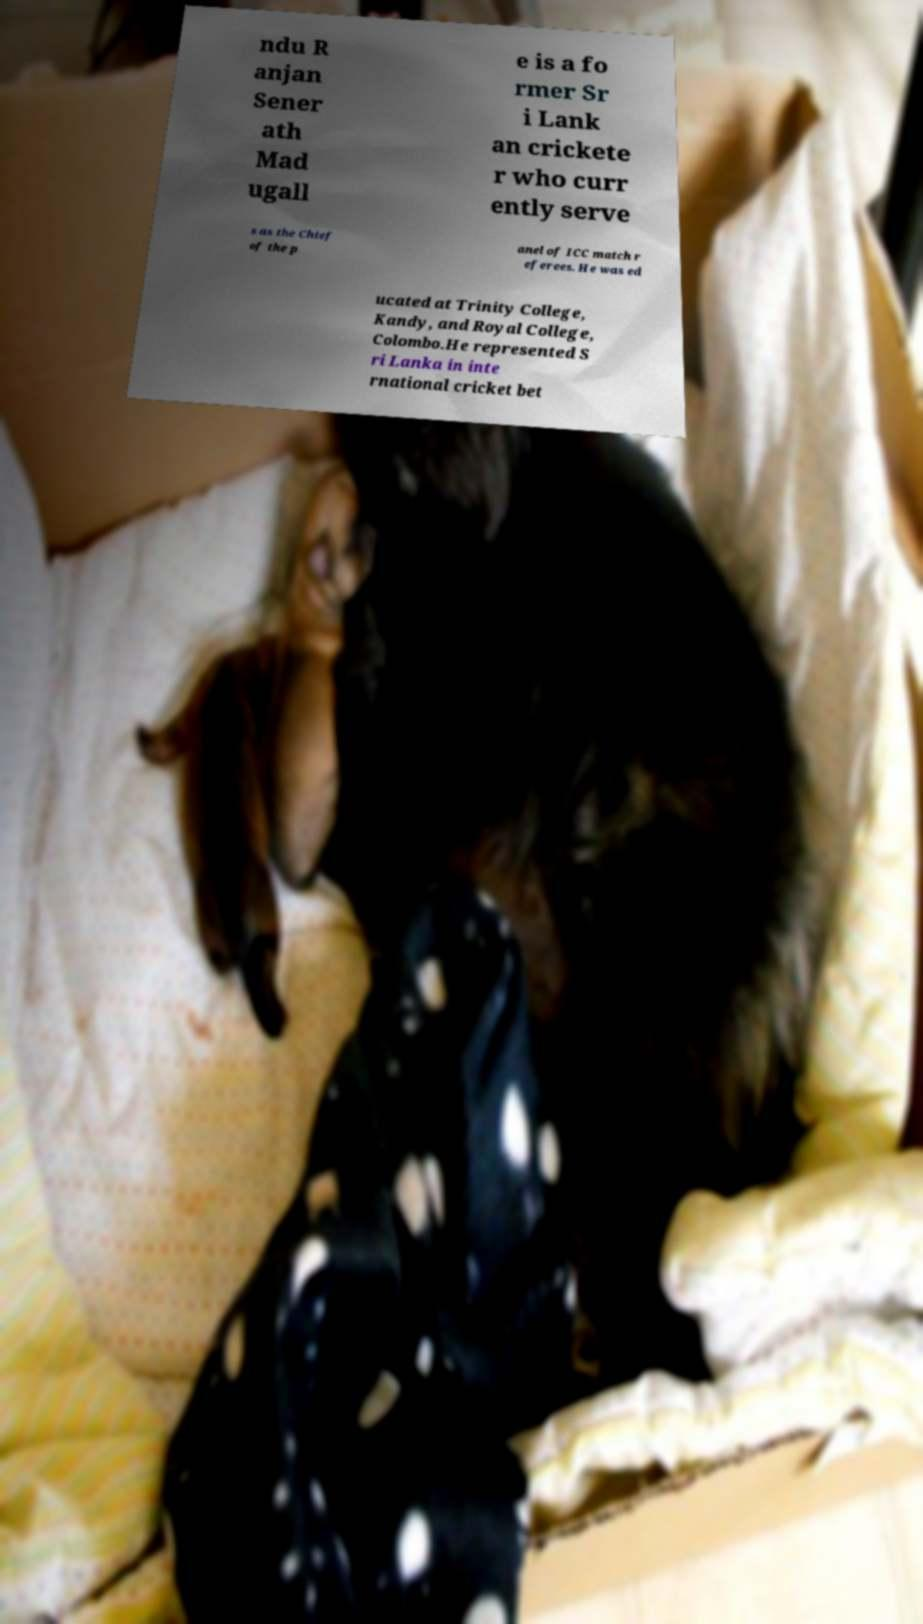For documentation purposes, I need the text within this image transcribed. Could you provide that? ndu R anjan Sener ath Mad ugall e is a fo rmer Sr i Lank an crickete r who curr ently serve s as the Chief of the p anel of ICC match r eferees. He was ed ucated at Trinity College, Kandy, and Royal College, Colombo.He represented S ri Lanka in inte rnational cricket bet 